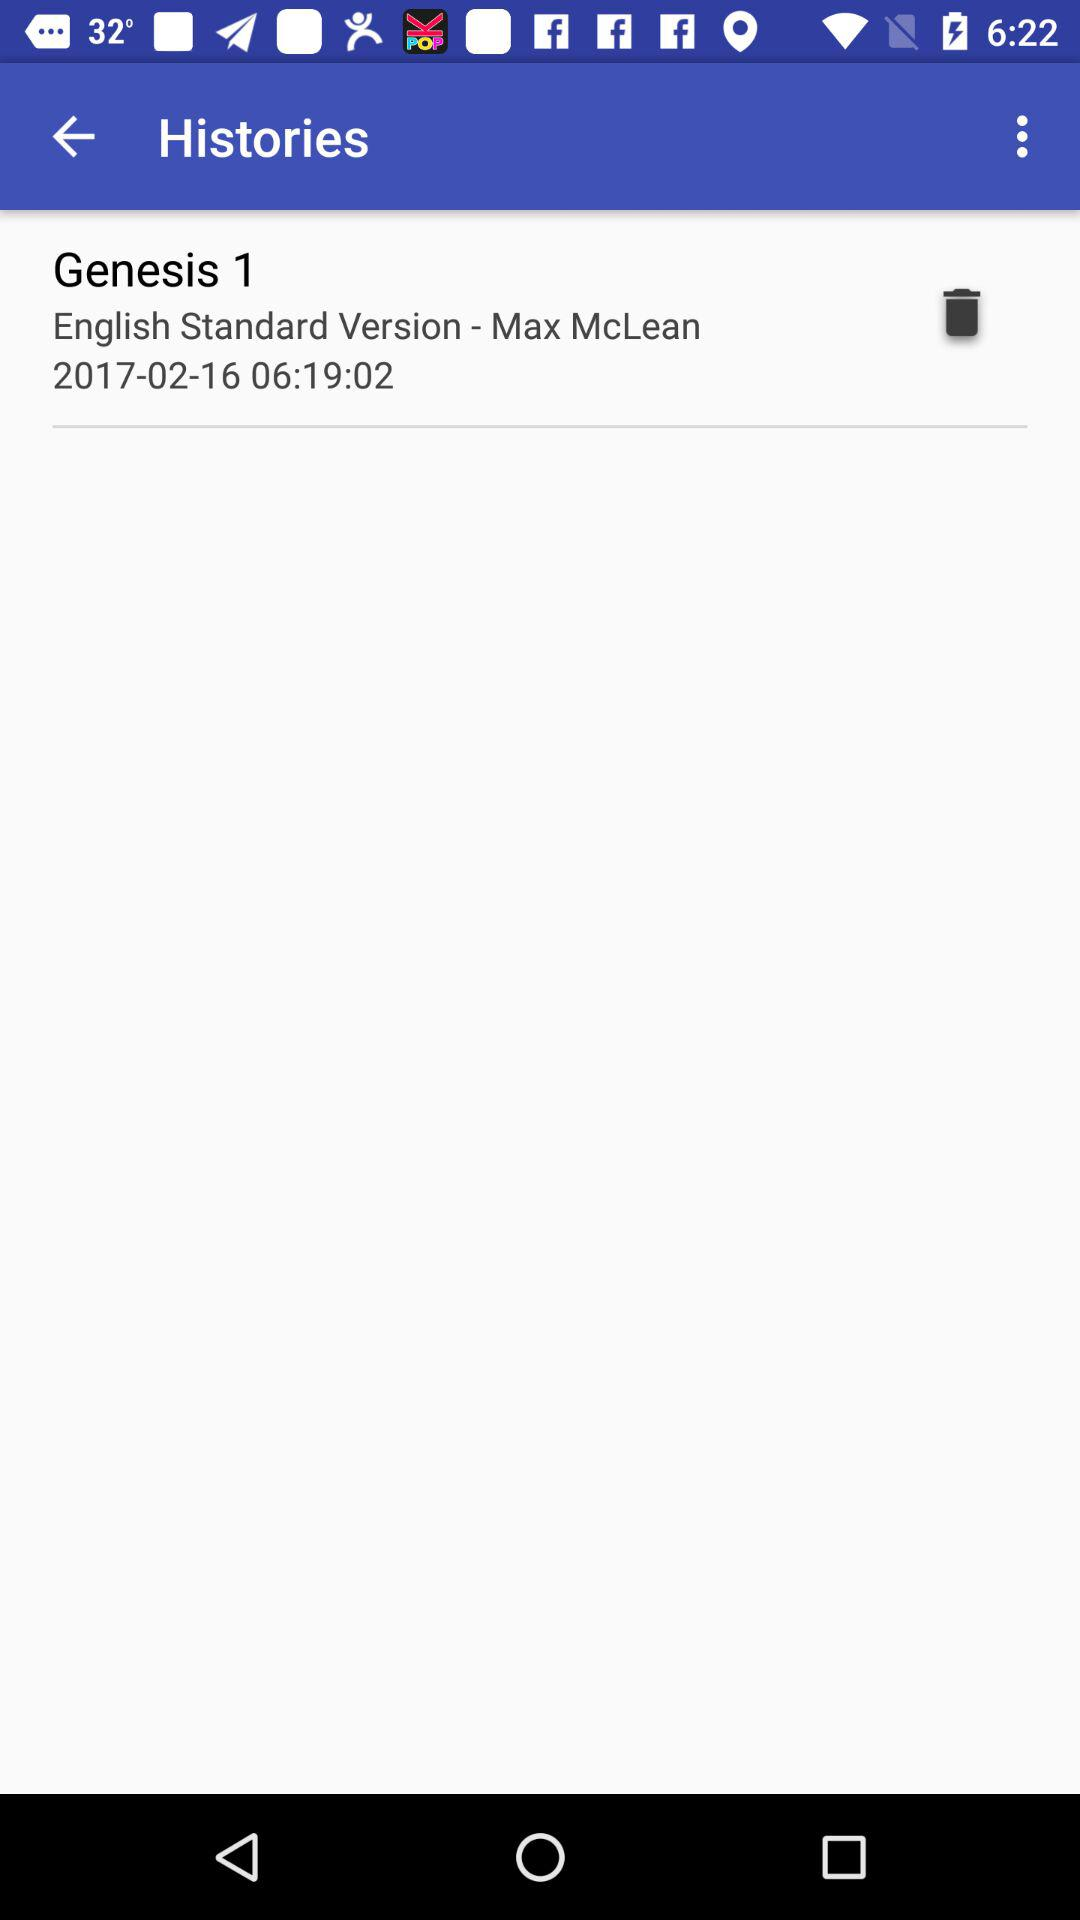What is the date? The date is February 16, 2017. 